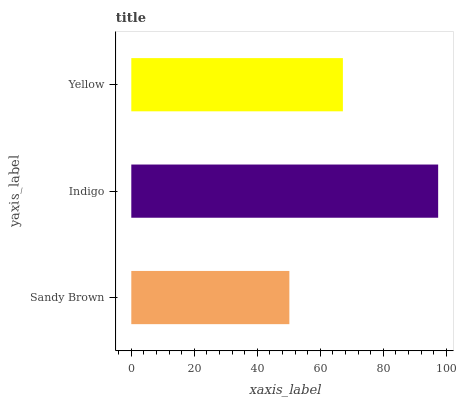Is Sandy Brown the minimum?
Answer yes or no. Yes. Is Indigo the maximum?
Answer yes or no. Yes. Is Yellow the minimum?
Answer yes or no. No. Is Yellow the maximum?
Answer yes or no. No. Is Indigo greater than Yellow?
Answer yes or no. Yes. Is Yellow less than Indigo?
Answer yes or no. Yes. Is Yellow greater than Indigo?
Answer yes or no. No. Is Indigo less than Yellow?
Answer yes or no. No. Is Yellow the high median?
Answer yes or no. Yes. Is Yellow the low median?
Answer yes or no. Yes. Is Indigo the high median?
Answer yes or no. No. Is Indigo the low median?
Answer yes or no. No. 